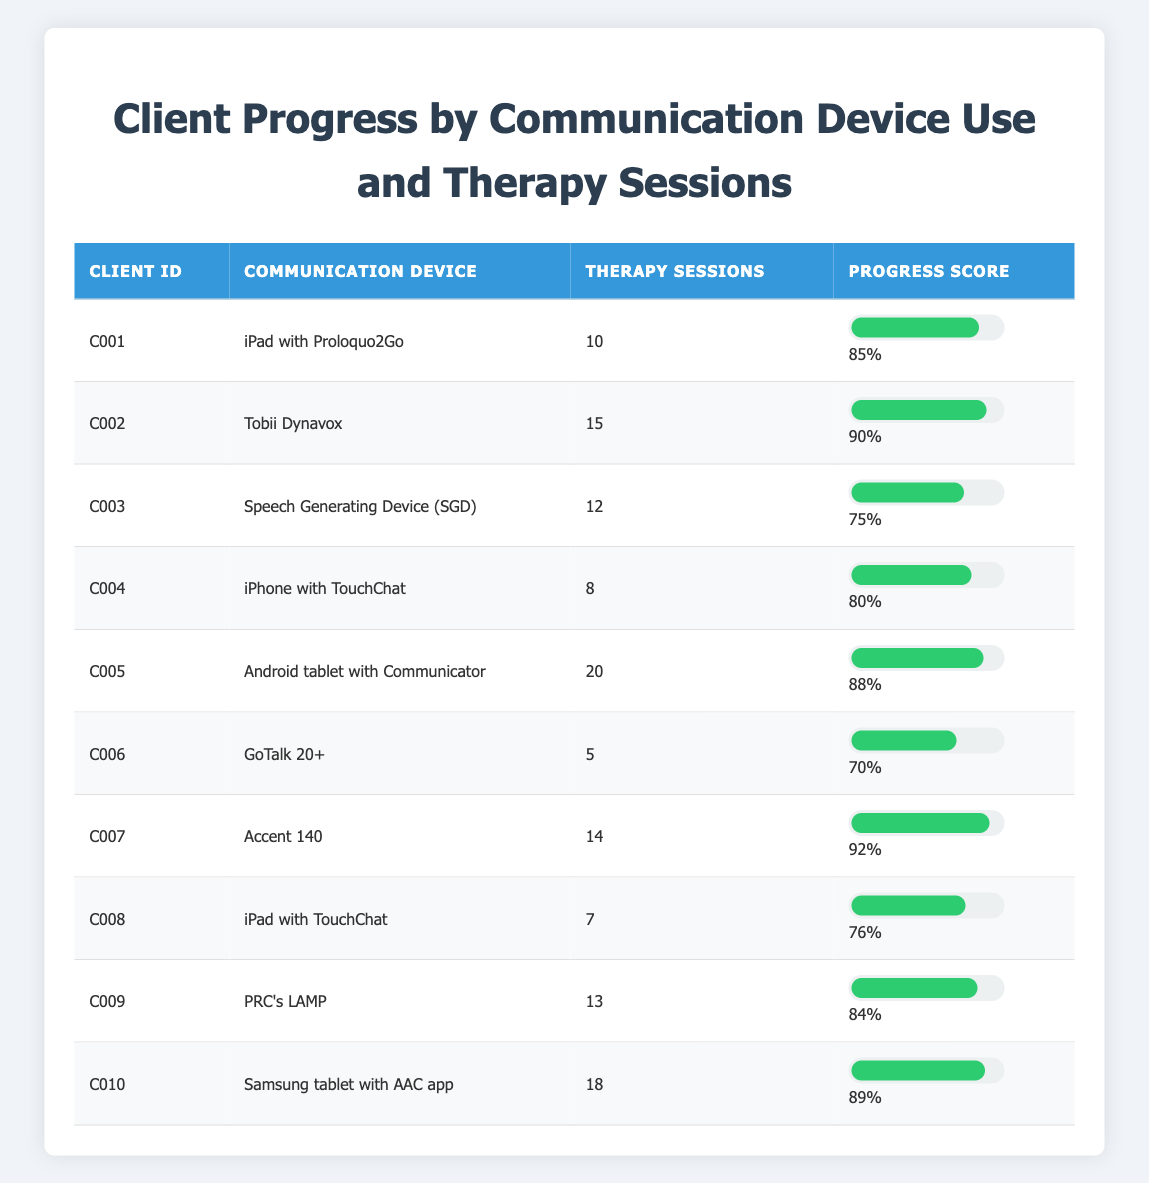What is the Progress Score for Client C007? The Progress Score column shows Client C007 has a score of 92% based on the data provided in the table.
Answer: 92% How many Therapy Sessions did Client C005 attend? The Therapy Sessions column indicates that Client C005 attended 20 sessions.
Answer: 20 Which client made the least progress with a score below 75? Looking through the Progress Score column, Client C006 has a score of 70%, which is the only score below 75%.
Answer: C006 What is the average Progress Score for all clients using an iPad? The clients using an iPad are C001 (85) and C008 (76). To find the average, sum the scores (85 + 76 = 161) and then divide by 2, which yields 80.5.
Answer: 80.5 Did any client achieve a Progress Score of 90 or above? Looking at the Progress Score column, Clients C002 (90) and C007 (92) both have scores of 90 or higher, confirming that at least two clients did achieve this score.
Answer: Yes Which Communication Device had the highest average Progress Score? Calculate the average for each device: iPad (80.5), Tobii Dynavox (90), SGD (75), iPhone (80), Android tablet (88), GoTalk (70), Accent (92), TouchChat (76), LAMP (84), Samsung (89). The device with the highest average is Tobii Dynavox with an average of 90.
Answer: Tobii Dynavox How many clients used less than 10 Therapy Sessions? Inspecting the Therapy Sessions column reveals that Clients C004 (8) and C006 (5) are the only ones with fewer than 10 sessions, totaling two clients.
Answer: 2 Is the Progress Score of Client C010 greater than the average Score of 85? Client C010 has a Progress Score of 89, which is indeed greater than the average Score of 85.
Answer: Yes What is the difference in Progress Scores between the best and worst performing clients? The highest score is 92 (Client C007) and the lowest score is 70 (Client C006). The difference is 92 - 70 = 22.
Answer: 22 